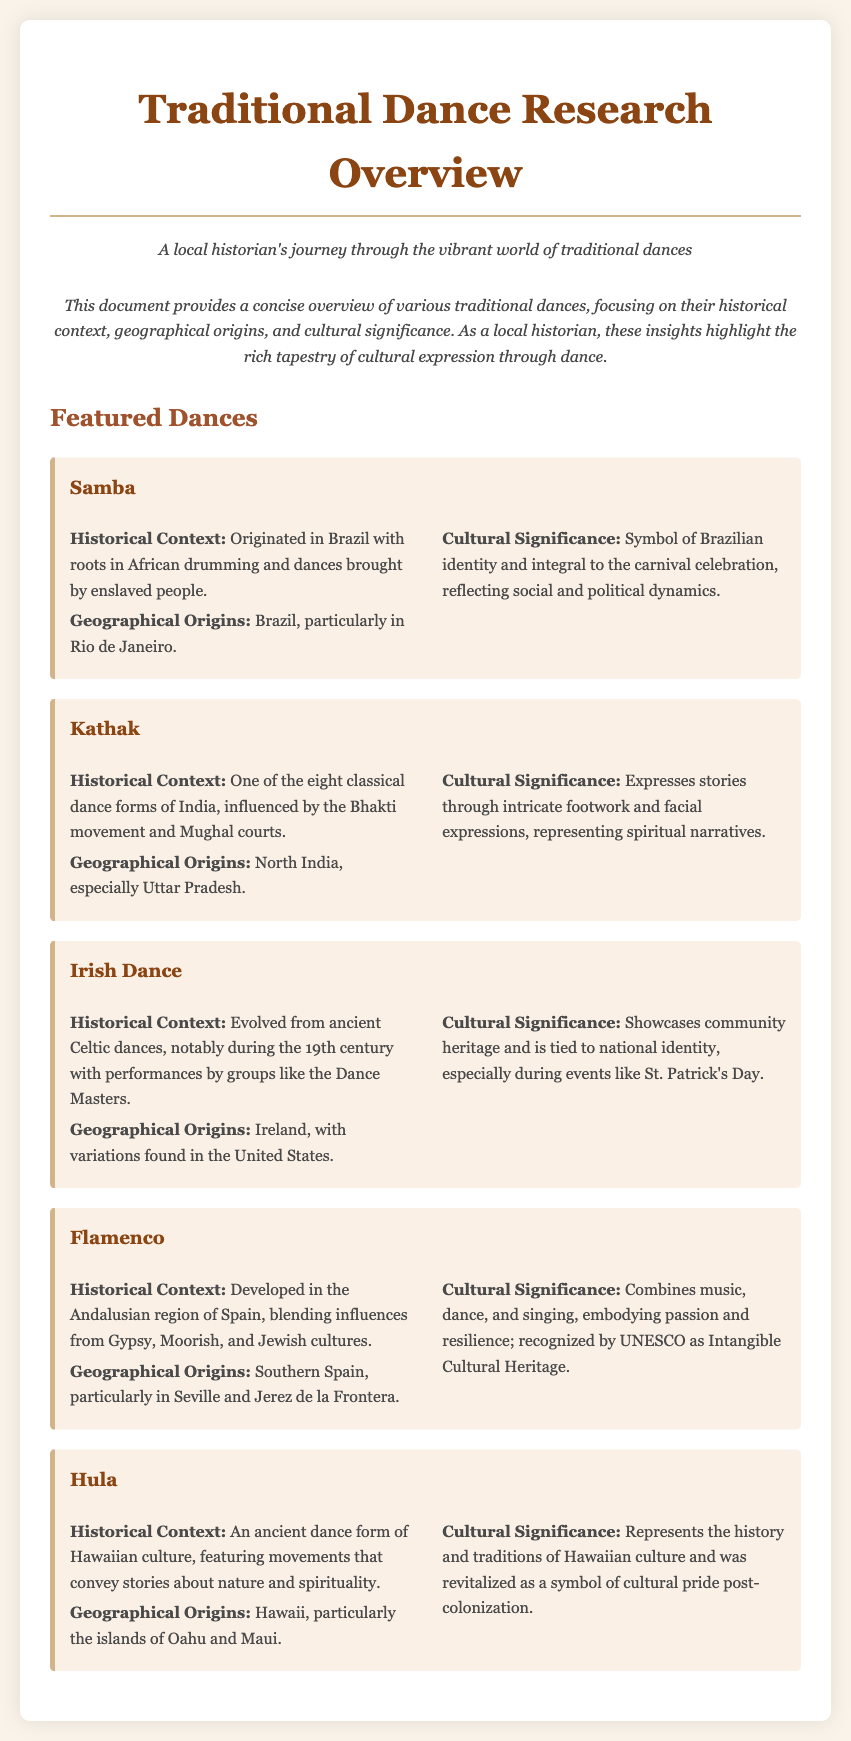What is the historical context of Samba? The historical context describes the origins and influences of the dance, which originated in Brazil with roots in African drumming and dances brought by enslaved people.
Answer: Originated in Brazil with roots in African drumming and dances brought by enslaved people Where did Kathak originate? The geographical origins section specifies that Kathak originated primarily in North India, especially Uttar Pradesh.
Answer: North India, especially Uttar Pradesh What embodies passion and resilience in Flamenco? The cultural significance highlights that Flamenco combines music, dance, and singing, embodying passion and resilience.
Answer: Combines music, dance, and singing During which event is Irish Dance particularly tied to national identity? The cultural significance mentions that Irish Dance is tied to national identity during events like St. Patrick's Day.
Answer: St. Patrick's Day What influence developed Hula? The historical context refers to Hula as an ancient dance form of Hawaiian culture featuring movements that convey stories about nature and spirituality.
Answer: Movements that convey stories about nature and spirituality Which dance is recognized by UNESCO as Intangible Cultural Heritage? The cultural significance indicates that Flamenco is recognized by UNESCO as Intangible Cultural Heritage.
Answer: Flamenco How many classical dance forms are there in India? The historical context of Kathak states that it is one of the eight classical dance forms of India.
Answer: Eight 